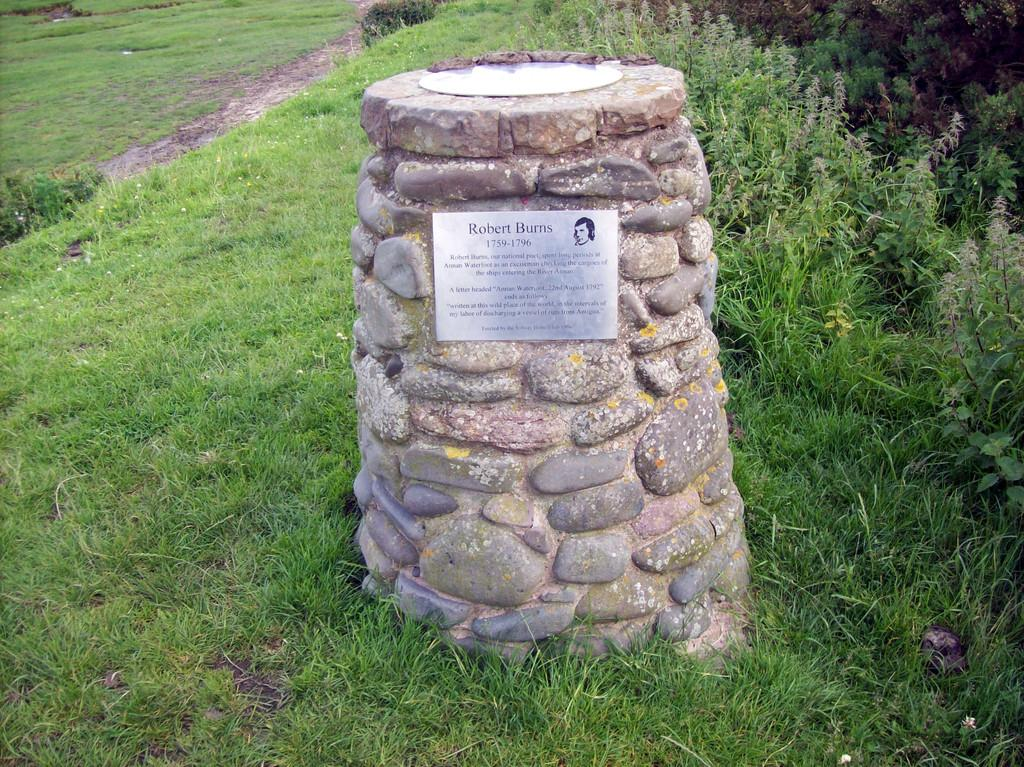What is the main subject in the center of the image? There is a headstone in the center of the image. Where is the headstone located? The headstone is on a grassland. What can be seen in the surrounding area? There is greenery around the area. How many pens are visible on the headstone in the image? There are no pens visible on the headstone in the image. What type of event is taking place near the headstone in the image? There is no event taking place near the headstone in the image. 